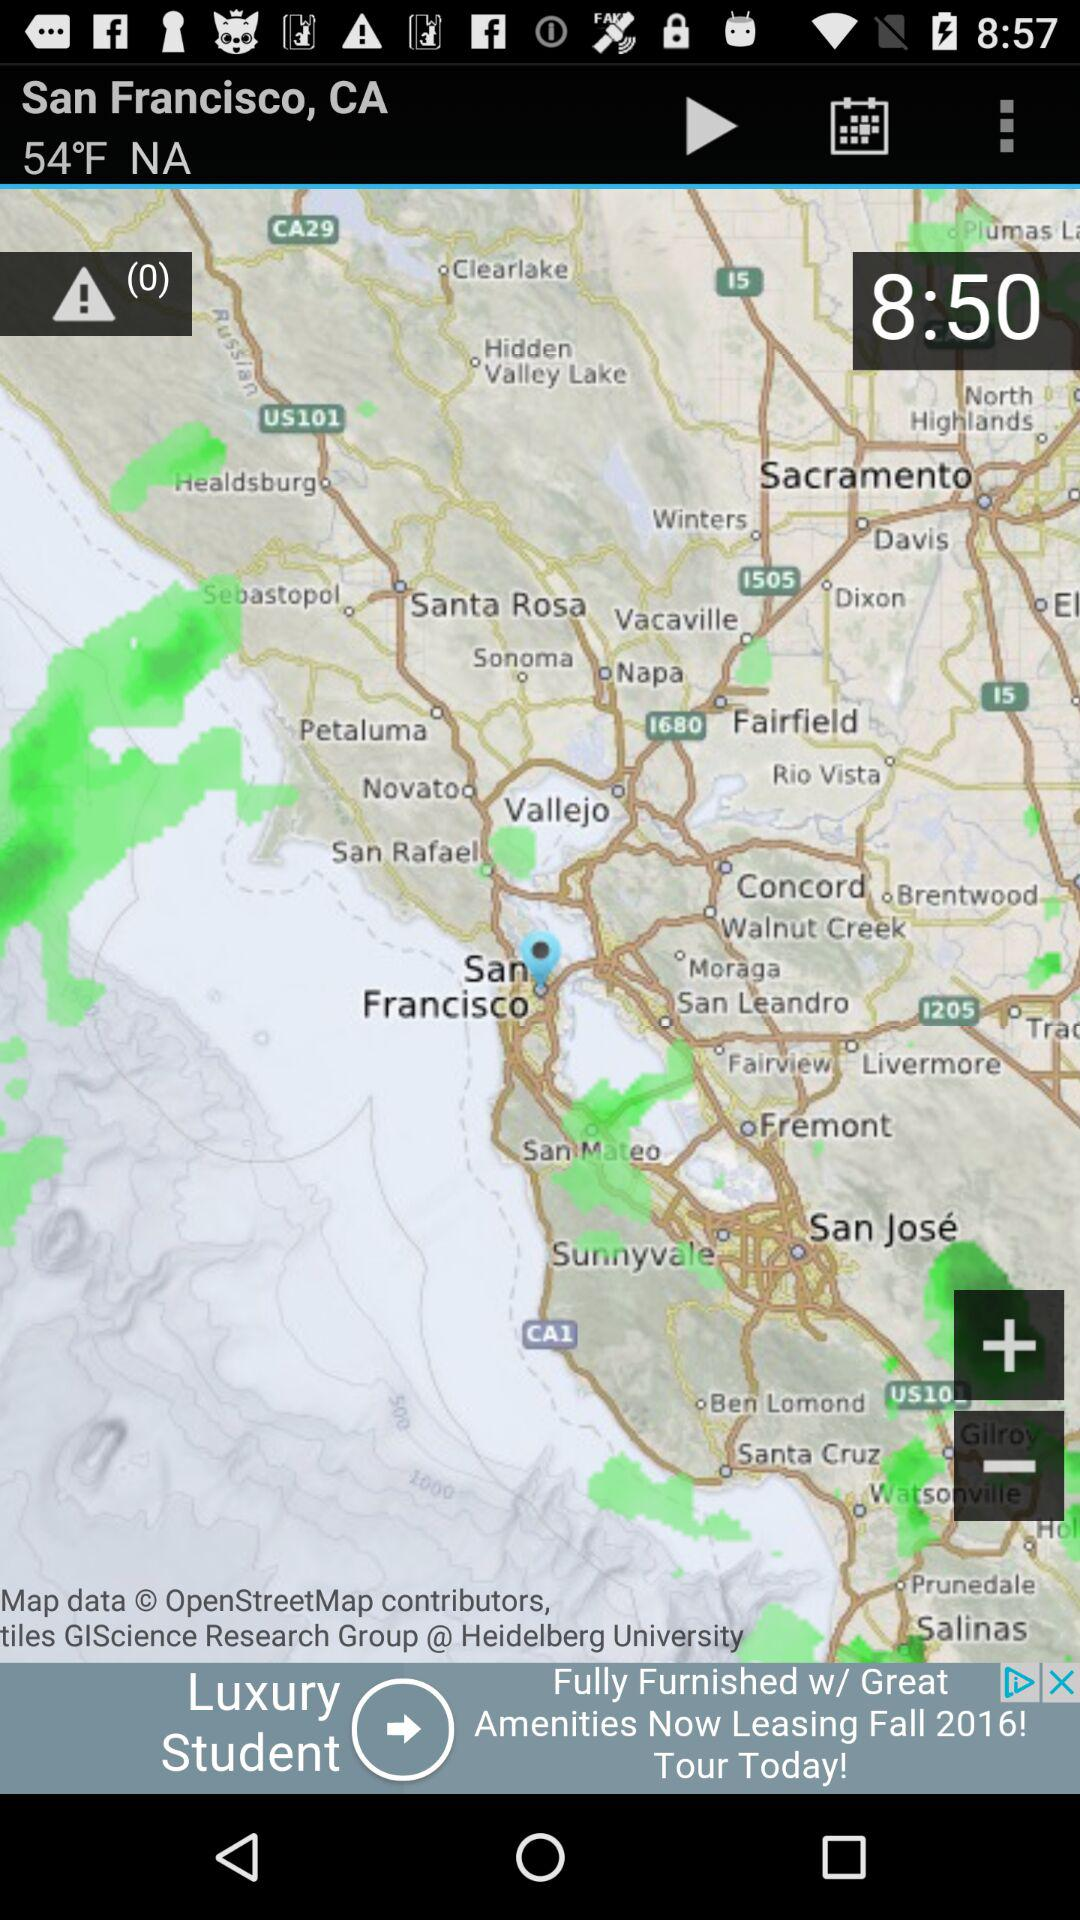What time is displayed on the screen? The time that is displayed on the screen is 8:50. 